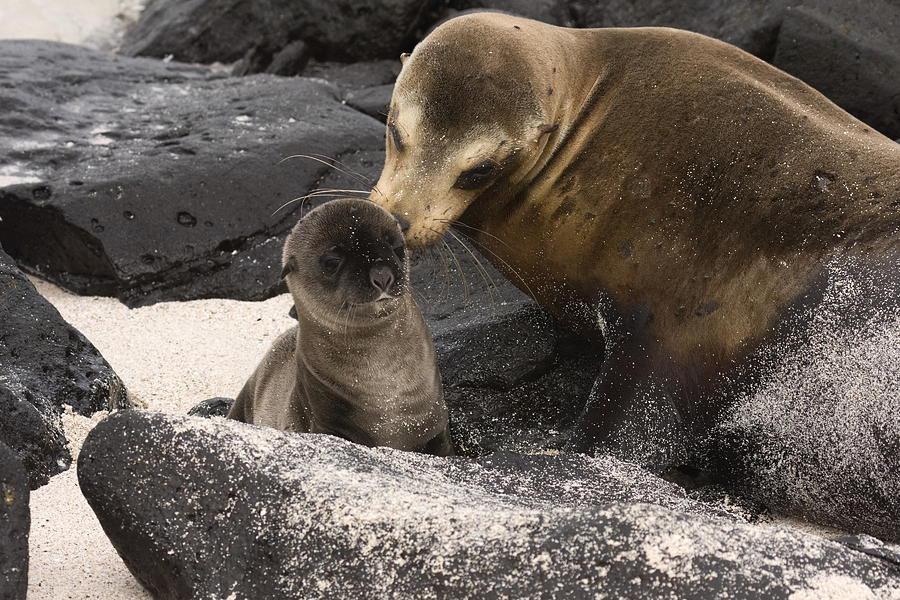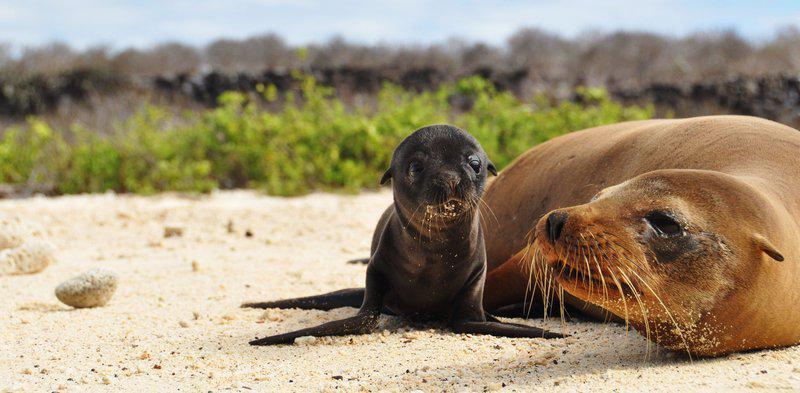The first image is the image on the left, the second image is the image on the right. For the images shown, is this caption "There are no baby animals in at least one of the images." true? Answer yes or no. No. The first image is the image on the left, the second image is the image on the right. For the images shown, is this caption "One image shows exactly three seals clustered together, in the foreground." true? Answer yes or no. No. 